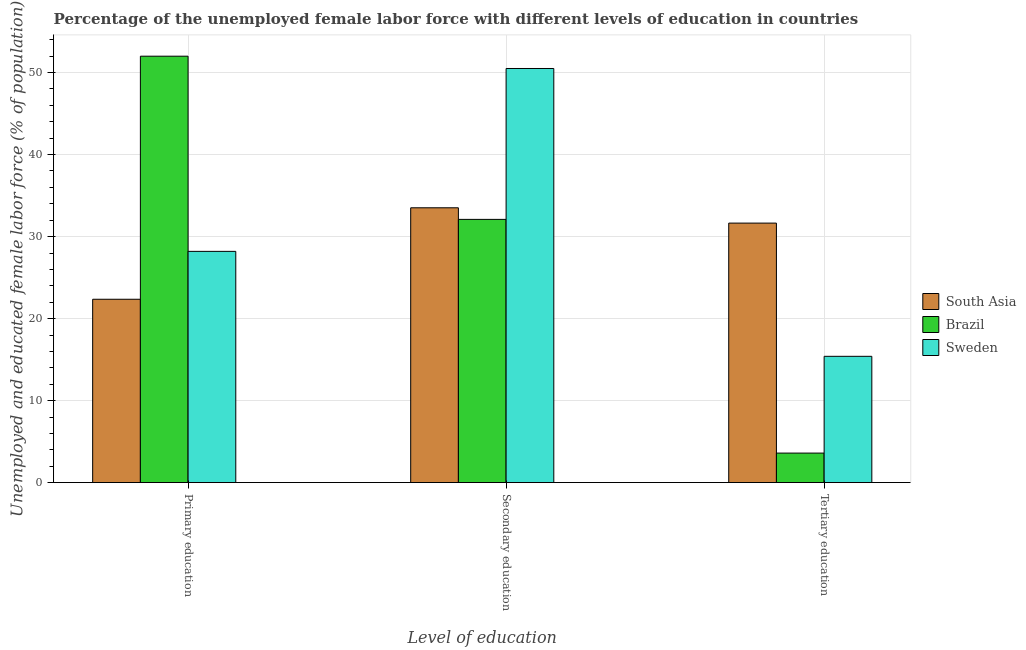How many different coloured bars are there?
Your answer should be very brief. 3. How many groups of bars are there?
Your response must be concise. 3. Are the number of bars per tick equal to the number of legend labels?
Your answer should be compact. Yes. Are the number of bars on each tick of the X-axis equal?
Keep it short and to the point. Yes. How many bars are there on the 3rd tick from the right?
Give a very brief answer. 3. What is the label of the 3rd group of bars from the left?
Make the answer very short. Tertiary education. What is the percentage of female labor force who received tertiary education in South Asia?
Your answer should be compact. 31.65. Across all countries, what is the minimum percentage of female labor force who received secondary education?
Offer a terse response. 32.1. In which country was the percentage of female labor force who received secondary education maximum?
Give a very brief answer. Sweden. In which country was the percentage of female labor force who received primary education minimum?
Keep it short and to the point. South Asia. What is the total percentage of female labor force who received tertiary education in the graph?
Your response must be concise. 50.65. What is the difference between the percentage of female labor force who received tertiary education in Brazil and that in Sweden?
Your answer should be compact. -11.8. What is the difference between the percentage of female labor force who received secondary education in Brazil and the percentage of female labor force who received tertiary education in Sweden?
Provide a succinct answer. 16.7. What is the average percentage of female labor force who received primary education per country?
Make the answer very short. 34.19. What is the difference between the percentage of female labor force who received secondary education and percentage of female labor force who received primary education in Sweden?
Keep it short and to the point. 22.3. In how many countries, is the percentage of female labor force who received primary education greater than 28 %?
Provide a short and direct response. 2. What is the ratio of the percentage of female labor force who received tertiary education in Sweden to that in Brazil?
Your answer should be very brief. 4.28. Is the difference between the percentage of female labor force who received secondary education in Brazil and South Asia greater than the difference between the percentage of female labor force who received primary education in Brazil and South Asia?
Your answer should be very brief. No. What is the difference between the highest and the second highest percentage of female labor force who received tertiary education?
Ensure brevity in your answer.  16.25. What is the difference between the highest and the lowest percentage of female labor force who received primary education?
Provide a succinct answer. 29.64. Is the sum of the percentage of female labor force who received tertiary education in Sweden and South Asia greater than the maximum percentage of female labor force who received secondary education across all countries?
Offer a very short reply. No. What does the 2nd bar from the right in Secondary education represents?
Make the answer very short. Brazil. How many bars are there?
Your response must be concise. 9. What is the difference between two consecutive major ticks on the Y-axis?
Your answer should be compact. 10. Does the graph contain grids?
Keep it short and to the point. Yes. What is the title of the graph?
Provide a short and direct response. Percentage of the unemployed female labor force with different levels of education in countries. Does "Upper middle income" appear as one of the legend labels in the graph?
Your response must be concise. No. What is the label or title of the X-axis?
Keep it short and to the point. Level of education. What is the label or title of the Y-axis?
Give a very brief answer. Unemployed and educated female labor force (% of population). What is the Unemployed and educated female labor force (% of population) of South Asia in Primary education?
Ensure brevity in your answer.  22.36. What is the Unemployed and educated female labor force (% of population) in Brazil in Primary education?
Make the answer very short. 52. What is the Unemployed and educated female labor force (% of population) in Sweden in Primary education?
Your response must be concise. 28.2. What is the Unemployed and educated female labor force (% of population) in South Asia in Secondary education?
Keep it short and to the point. 33.51. What is the Unemployed and educated female labor force (% of population) of Brazil in Secondary education?
Offer a terse response. 32.1. What is the Unemployed and educated female labor force (% of population) of Sweden in Secondary education?
Offer a very short reply. 50.5. What is the Unemployed and educated female labor force (% of population) in South Asia in Tertiary education?
Ensure brevity in your answer.  31.65. What is the Unemployed and educated female labor force (% of population) of Brazil in Tertiary education?
Give a very brief answer. 3.6. What is the Unemployed and educated female labor force (% of population) in Sweden in Tertiary education?
Your answer should be very brief. 15.4. Across all Level of education, what is the maximum Unemployed and educated female labor force (% of population) of South Asia?
Your answer should be compact. 33.51. Across all Level of education, what is the maximum Unemployed and educated female labor force (% of population) in Brazil?
Keep it short and to the point. 52. Across all Level of education, what is the maximum Unemployed and educated female labor force (% of population) in Sweden?
Make the answer very short. 50.5. Across all Level of education, what is the minimum Unemployed and educated female labor force (% of population) of South Asia?
Your answer should be very brief. 22.36. Across all Level of education, what is the minimum Unemployed and educated female labor force (% of population) in Brazil?
Your answer should be very brief. 3.6. Across all Level of education, what is the minimum Unemployed and educated female labor force (% of population) in Sweden?
Provide a succinct answer. 15.4. What is the total Unemployed and educated female labor force (% of population) in South Asia in the graph?
Offer a terse response. 87.52. What is the total Unemployed and educated female labor force (% of population) in Brazil in the graph?
Make the answer very short. 87.7. What is the total Unemployed and educated female labor force (% of population) of Sweden in the graph?
Provide a succinct answer. 94.1. What is the difference between the Unemployed and educated female labor force (% of population) in South Asia in Primary education and that in Secondary education?
Keep it short and to the point. -11.16. What is the difference between the Unemployed and educated female labor force (% of population) of Sweden in Primary education and that in Secondary education?
Make the answer very short. -22.3. What is the difference between the Unemployed and educated female labor force (% of population) of South Asia in Primary education and that in Tertiary education?
Give a very brief answer. -9.29. What is the difference between the Unemployed and educated female labor force (% of population) in Brazil in Primary education and that in Tertiary education?
Your answer should be compact. 48.4. What is the difference between the Unemployed and educated female labor force (% of population) in Sweden in Primary education and that in Tertiary education?
Offer a terse response. 12.8. What is the difference between the Unemployed and educated female labor force (% of population) of South Asia in Secondary education and that in Tertiary education?
Offer a terse response. 1.87. What is the difference between the Unemployed and educated female labor force (% of population) in Brazil in Secondary education and that in Tertiary education?
Your answer should be compact. 28.5. What is the difference between the Unemployed and educated female labor force (% of population) in Sweden in Secondary education and that in Tertiary education?
Your answer should be compact. 35.1. What is the difference between the Unemployed and educated female labor force (% of population) of South Asia in Primary education and the Unemployed and educated female labor force (% of population) of Brazil in Secondary education?
Make the answer very short. -9.74. What is the difference between the Unemployed and educated female labor force (% of population) in South Asia in Primary education and the Unemployed and educated female labor force (% of population) in Sweden in Secondary education?
Offer a very short reply. -28.14. What is the difference between the Unemployed and educated female labor force (% of population) of Brazil in Primary education and the Unemployed and educated female labor force (% of population) of Sweden in Secondary education?
Provide a succinct answer. 1.5. What is the difference between the Unemployed and educated female labor force (% of population) of South Asia in Primary education and the Unemployed and educated female labor force (% of population) of Brazil in Tertiary education?
Provide a short and direct response. 18.76. What is the difference between the Unemployed and educated female labor force (% of population) in South Asia in Primary education and the Unemployed and educated female labor force (% of population) in Sweden in Tertiary education?
Your answer should be compact. 6.96. What is the difference between the Unemployed and educated female labor force (% of population) in Brazil in Primary education and the Unemployed and educated female labor force (% of population) in Sweden in Tertiary education?
Keep it short and to the point. 36.6. What is the difference between the Unemployed and educated female labor force (% of population) of South Asia in Secondary education and the Unemployed and educated female labor force (% of population) of Brazil in Tertiary education?
Provide a short and direct response. 29.91. What is the difference between the Unemployed and educated female labor force (% of population) of South Asia in Secondary education and the Unemployed and educated female labor force (% of population) of Sweden in Tertiary education?
Your answer should be compact. 18.11. What is the average Unemployed and educated female labor force (% of population) of South Asia per Level of education?
Your answer should be compact. 29.17. What is the average Unemployed and educated female labor force (% of population) of Brazil per Level of education?
Give a very brief answer. 29.23. What is the average Unemployed and educated female labor force (% of population) in Sweden per Level of education?
Give a very brief answer. 31.37. What is the difference between the Unemployed and educated female labor force (% of population) of South Asia and Unemployed and educated female labor force (% of population) of Brazil in Primary education?
Your answer should be very brief. -29.64. What is the difference between the Unemployed and educated female labor force (% of population) of South Asia and Unemployed and educated female labor force (% of population) of Sweden in Primary education?
Offer a very short reply. -5.84. What is the difference between the Unemployed and educated female labor force (% of population) of Brazil and Unemployed and educated female labor force (% of population) of Sweden in Primary education?
Provide a short and direct response. 23.8. What is the difference between the Unemployed and educated female labor force (% of population) in South Asia and Unemployed and educated female labor force (% of population) in Brazil in Secondary education?
Keep it short and to the point. 1.41. What is the difference between the Unemployed and educated female labor force (% of population) in South Asia and Unemployed and educated female labor force (% of population) in Sweden in Secondary education?
Your answer should be compact. -16.99. What is the difference between the Unemployed and educated female labor force (% of population) in Brazil and Unemployed and educated female labor force (% of population) in Sweden in Secondary education?
Keep it short and to the point. -18.4. What is the difference between the Unemployed and educated female labor force (% of population) in South Asia and Unemployed and educated female labor force (% of population) in Brazil in Tertiary education?
Offer a very short reply. 28.05. What is the difference between the Unemployed and educated female labor force (% of population) in South Asia and Unemployed and educated female labor force (% of population) in Sweden in Tertiary education?
Offer a very short reply. 16.25. What is the difference between the Unemployed and educated female labor force (% of population) of Brazil and Unemployed and educated female labor force (% of population) of Sweden in Tertiary education?
Ensure brevity in your answer.  -11.8. What is the ratio of the Unemployed and educated female labor force (% of population) of South Asia in Primary education to that in Secondary education?
Provide a short and direct response. 0.67. What is the ratio of the Unemployed and educated female labor force (% of population) of Brazil in Primary education to that in Secondary education?
Give a very brief answer. 1.62. What is the ratio of the Unemployed and educated female labor force (% of population) of Sweden in Primary education to that in Secondary education?
Keep it short and to the point. 0.56. What is the ratio of the Unemployed and educated female labor force (% of population) of South Asia in Primary education to that in Tertiary education?
Offer a very short reply. 0.71. What is the ratio of the Unemployed and educated female labor force (% of population) of Brazil in Primary education to that in Tertiary education?
Your response must be concise. 14.44. What is the ratio of the Unemployed and educated female labor force (% of population) in Sweden in Primary education to that in Tertiary education?
Offer a terse response. 1.83. What is the ratio of the Unemployed and educated female labor force (% of population) of South Asia in Secondary education to that in Tertiary education?
Offer a very short reply. 1.06. What is the ratio of the Unemployed and educated female labor force (% of population) in Brazil in Secondary education to that in Tertiary education?
Keep it short and to the point. 8.92. What is the ratio of the Unemployed and educated female labor force (% of population) in Sweden in Secondary education to that in Tertiary education?
Make the answer very short. 3.28. What is the difference between the highest and the second highest Unemployed and educated female labor force (% of population) in South Asia?
Offer a very short reply. 1.87. What is the difference between the highest and the second highest Unemployed and educated female labor force (% of population) of Sweden?
Your response must be concise. 22.3. What is the difference between the highest and the lowest Unemployed and educated female labor force (% of population) in South Asia?
Your response must be concise. 11.16. What is the difference between the highest and the lowest Unemployed and educated female labor force (% of population) in Brazil?
Provide a succinct answer. 48.4. What is the difference between the highest and the lowest Unemployed and educated female labor force (% of population) of Sweden?
Ensure brevity in your answer.  35.1. 